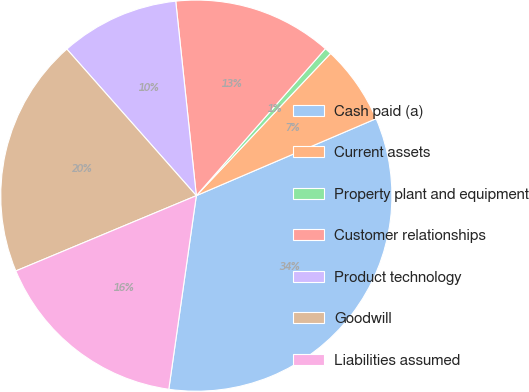<chart> <loc_0><loc_0><loc_500><loc_500><pie_chart><fcel>Cash paid (a)<fcel>Current assets<fcel>Property plant and equipment<fcel>Customer relationships<fcel>Product technology<fcel>Goodwill<fcel>Liabilities assumed<nl><fcel>33.69%<fcel>6.52%<fcel>0.57%<fcel>13.15%<fcel>9.84%<fcel>19.77%<fcel>16.46%<nl></chart> 